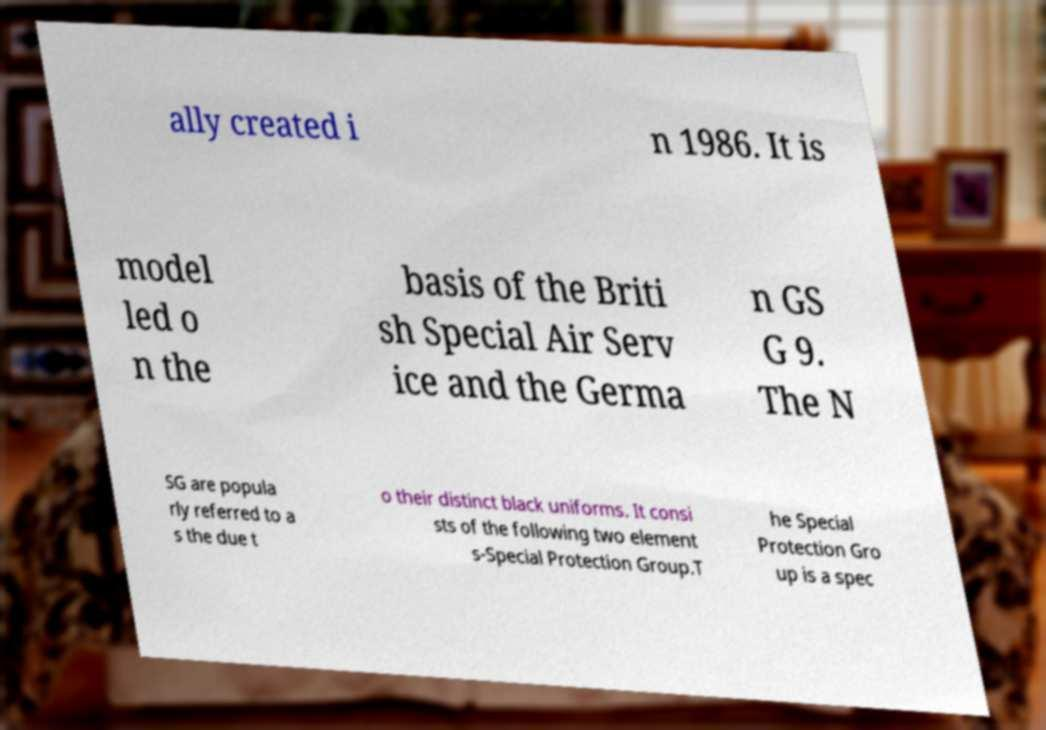Please identify and transcribe the text found in this image. ally created i n 1986. It is model led o n the basis of the Briti sh Special Air Serv ice and the Germa n GS G 9. The N SG are popula rly referred to a s the due t o their distinct black uniforms. It consi sts of the following two element s-Special Protection Group.T he Special Protection Gro up is a spec 